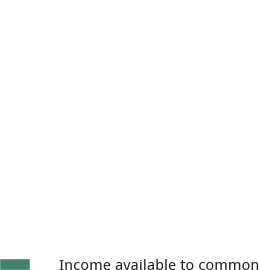Convert chart to OTSL. <chart><loc_0><loc_0><loc_500><loc_500><pie_chart><fcel>Income available to common<nl><fcel>100.0%<nl></chart> 